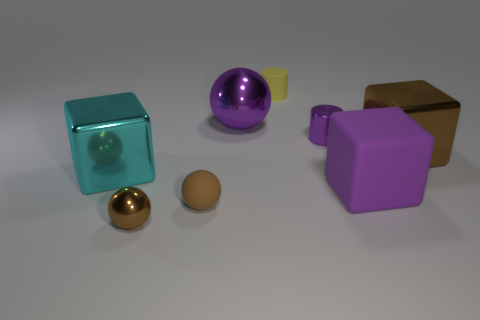Is the rubber cylinder the same color as the big ball?
Provide a short and direct response. No. The big cyan object that is made of the same material as the large brown block is what shape?
Your answer should be compact. Cube. How many tiny brown shiny things have the same shape as the large purple matte thing?
Offer a terse response. 0. There is a brown metal thing that is right of the rubber object to the right of the tiny purple shiny cylinder; what shape is it?
Make the answer very short. Cube. Is the size of the brown sphere that is behind the brown metallic sphere the same as the purple cylinder?
Make the answer very short. Yes. There is a cube that is both to the right of the yellow matte cylinder and behind the rubber cube; how big is it?
Your answer should be very brief. Large. What number of cyan metallic cubes are the same size as the brown matte sphere?
Offer a terse response. 0. There is a shiny cube that is on the right side of the large shiny sphere; what number of rubber things are right of it?
Provide a short and direct response. 0. There is a tiny rubber thing behind the purple matte object; does it have the same color as the large rubber object?
Keep it short and to the point. No. Are there any balls behind the tiny cylinder on the left side of the tiny object right of the yellow matte cylinder?
Your answer should be compact. No. 